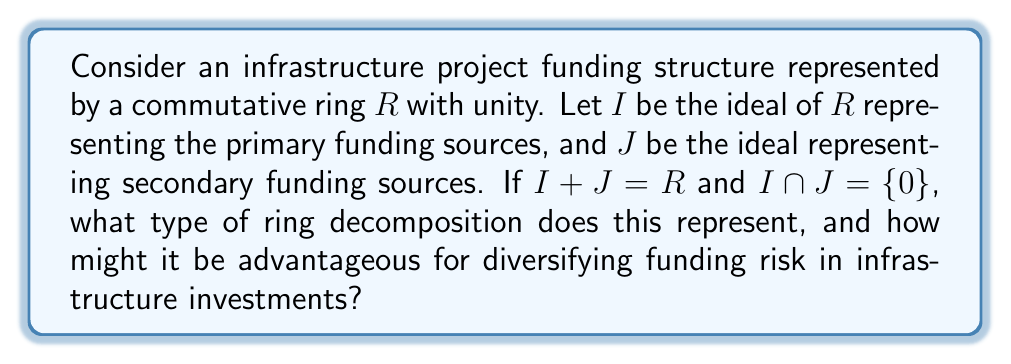What is the answer to this math problem? To analyze this problem, let's break it down step-by-step:

1) We are given a commutative ring $R$ with unity, representing the entire funding structure of an infrastructure project.

2) Two ideals are defined:
   $I$: representing primary funding sources
   $J$: representing secondary funding sources

3) We are given two conditions:
   a) $I + J = R$
   b) $I \cap J = \{0\}$

4) These conditions are precisely the requirements for a direct sum decomposition of the ring $R$.

5) In ring theory, when a ring $R$ can be expressed as $R = I \oplus J$, where $I$ and $J$ are ideals of $R$, we call this a direct sum decomposition.

6) The direct sum decomposition implies that every element $r \in R$ can be uniquely expressed as $r = i + j$, where $i \in I$ and $j \in J$.

7) In the context of infrastructure project funding:
   - This decomposition represents a clear separation between primary and secondary funding sources.
   - Each funding component can be uniquely attributed to either the primary or secondary source.
   - There is no overlap between the two funding sources (as $I \cap J = \{0\}$).

8) Advantages for diversifying funding risk:
   - Clear segregation of funding sources allows for better risk management.
   - If one funding source faces issues, the other remains unaffected.
   - It allows for tailored strategies for each funding component.
   - Easier to analyze and adjust the balance between primary and secondary funding.

9) In ring theory, this structure is isomorphic to the direct product of rings $I \times J$, which further emphasizes the independence of the two funding components.
Answer: This represents a direct sum decomposition of the ring $R$, denoted as $R = I \oplus J$. This structure is advantageous for diversifying funding risk in infrastructure investments as it provides a clear separation between primary and secondary funding sources, allowing for independent risk management strategies and easier analysis of the overall funding structure. 